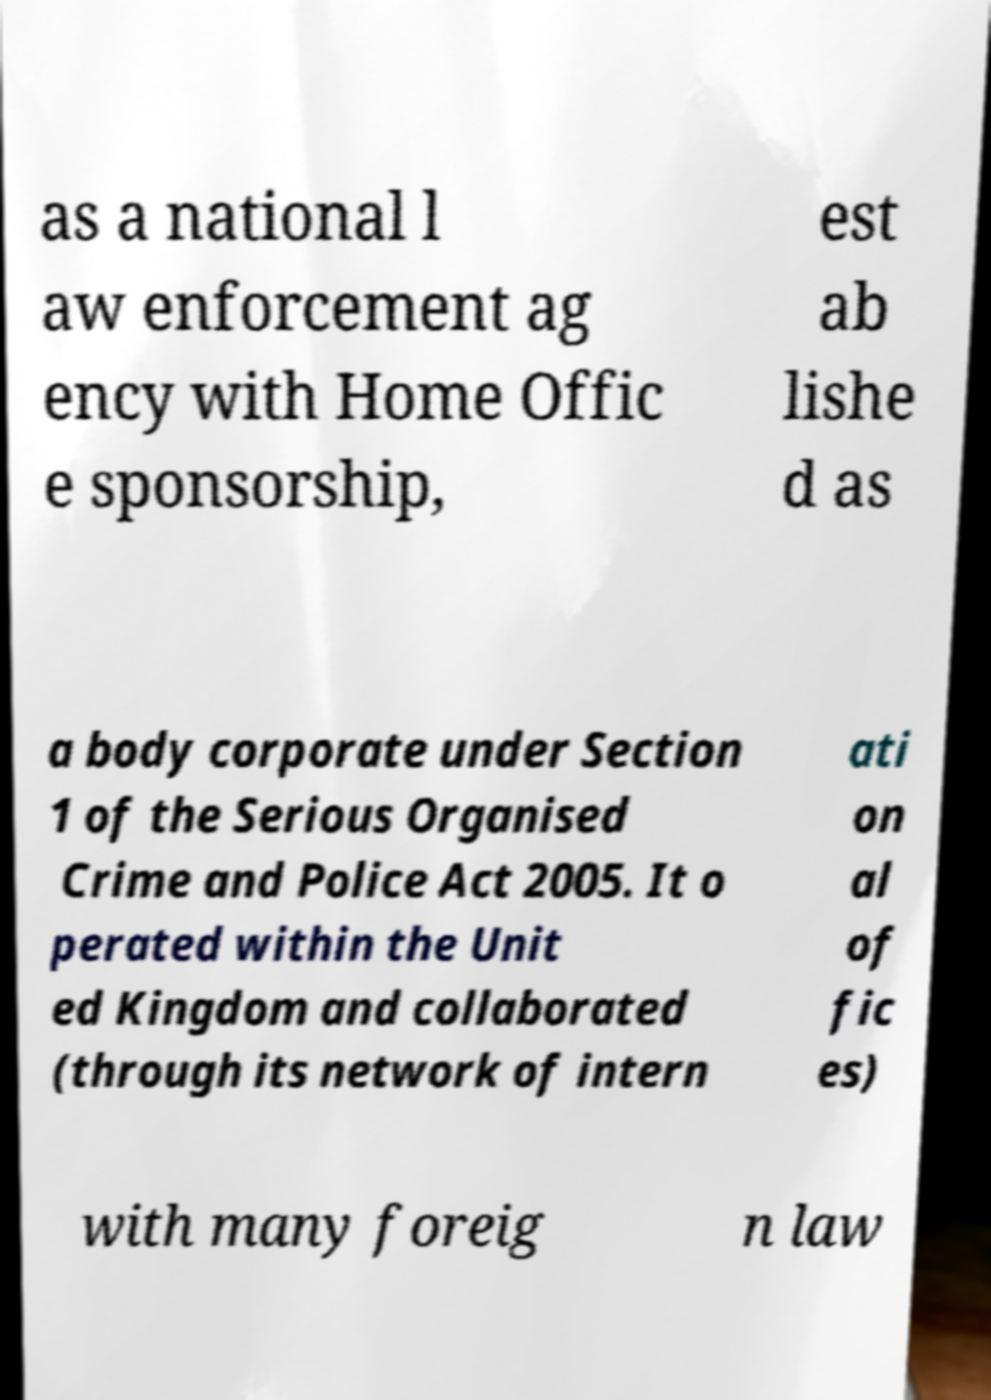Can you accurately transcribe the text from the provided image for me? as a national l aw enforcement ag ency with Home Offic e sponsorship, est ab lishe d as a body corporate under Section 1 of the Serious Organised Crime and Police Act 2005. It o perated within the Unit ed Kingdom and collaborated (through its network of intern ati on al of fic es) with many foreig n law 